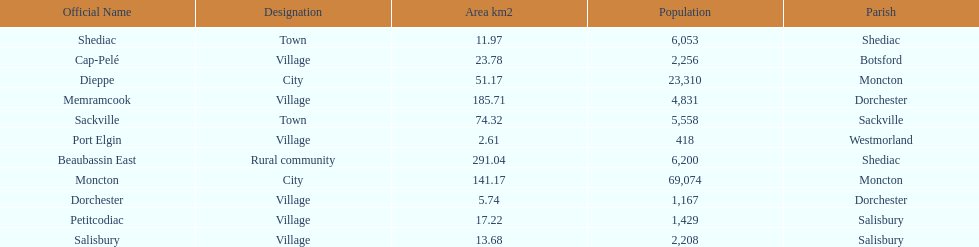Which city has the largest population? Moncton. 